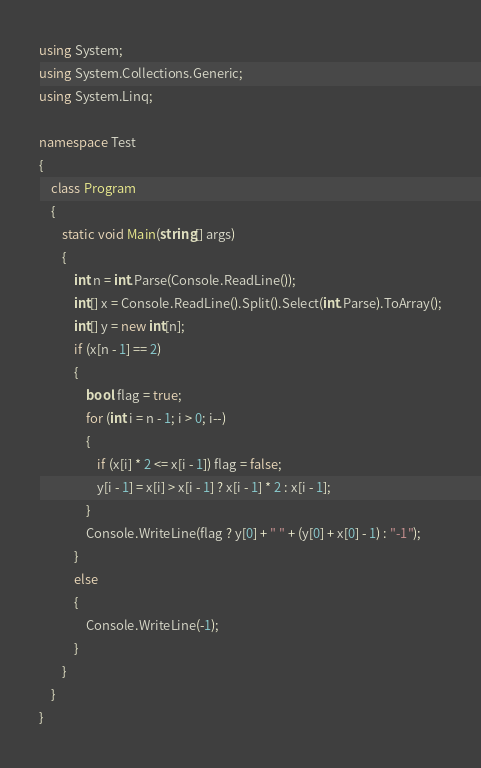Convert code to text. <code><loc_0><loc_0><loc_500><loc_500><_C#_>using System;
using System.Collections.Generic;
using System.Linq;

namespace Test
{
    class Program
    {
        static void Main(string[] args)
        {
            int n = int.Parse(Console.ReadLine());
            int[] x = Console.ReadLine().Split().Select(int.Parse).ToArray();
            int[] y = new int[n];
            if (x[n - 1] == 2)
            {
                bool flag = true;
                for (int i = n - 1; i > 0; i--)
                {
                    if (x[i] * 2 <= x[i - 1]) flag = false;
                    y[i - 1] = x[i] > x[i - 1] ? x[i - 1] * 2 : x[i - 1];
                }
                Console.WriteLine(flag ? y[0] + " " + (y[0] + x[0] - 1) : "-1");
            }
            else
            {
                Console.WriteLine(-1);
            }
        }
    }
}</code> 